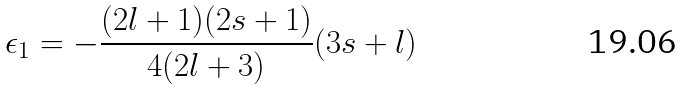Convert formula to latex. <formula><loc_0><loc_0><loc_500><loc_500>\epsilon _ { 1 } = - \frac { ( 2 l + 1 ) ( 2 s + 1 ) } { 4 ( 2 l + 3 ) } ( 3 s + l )</formula> 